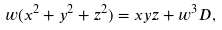Convert formula to latex. <formula><loc_0><loc_0><loc_500><loc_500>w ( x ^ { 2 } + y ^ { 2 } + z ^ { 2 } ) = x y z + w ^ { 3 } D ,</formula> 